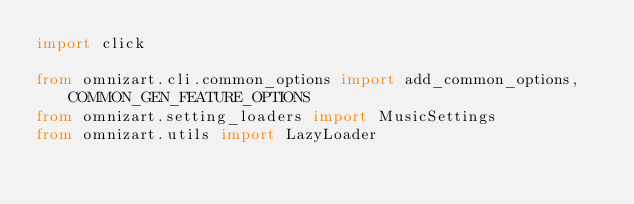Convert code to text. <code><loc_0><loc_0><loc_500><loc_500><_Python_>import click

from omnizart.cli.common_options import add_common_options, COMMON_GEN_FEATURE_OPTIONS
from omnizart.setting_loaders import MusicSettings
from omnizart.utils import LazyLoader

</code> 